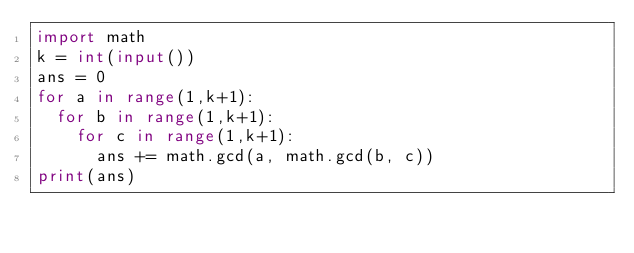<code> <loc_0><loc_0><loc_500><loc_500><_Python_>import math
k = int(input())
ans = 0
for a in range(1,k+1):
  for b in range(1,k+1):
    for c in range(1,k+1):
      ans += math.gcd(a, math.gcd(b, c))
print(ans)</code> 